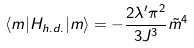<formula> <loc_0><loc_0><loc_500><loc_500>\langle m | H _ { h . d . } | m \rangle = - \frac { 2 \lambda ^ { \prime } \pi ^ { 2 } } { 3 J ^ { 3 } } \tilde { m } ^ { 4 }</formula> 